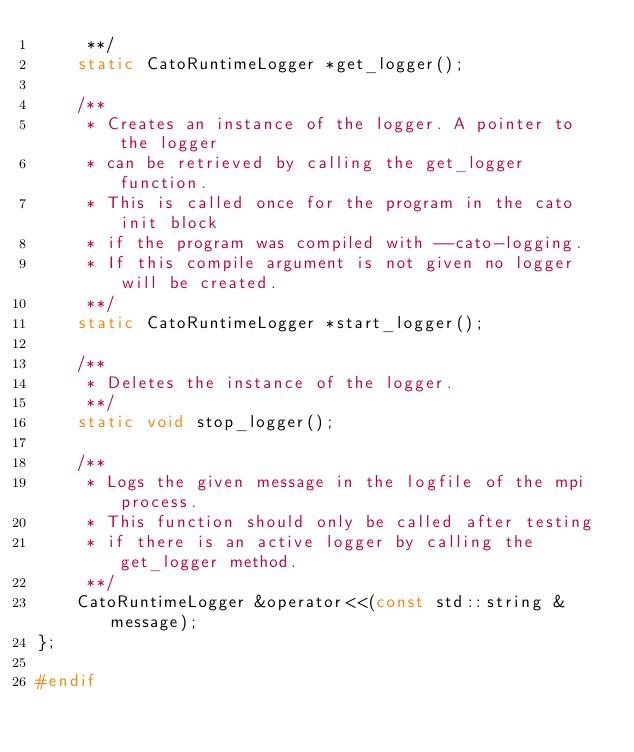<code> <loc_0><loc_0><loc_500><loc_500><_C_>     **/
    static CatoRuntimeLogger *get_logger();

    /**
     * Creates an instance of the logger. A pointer to the logger
     * can be retrieved by calling the get_logger function.
     * This is called once for the program in the cato init block
     * if the program was compiled with --cato-logging.
     * If this compile argument is not given no logger will be created.
     **/
    static CatoRuntimeLogger *start_logger();

    /**
     * Deletes the instance of the logger.
     **/
    static void stop_logger();

    /**
     * Logs the given message in the logfile of the mpi process.
     * This function should only be called after testing
     * if there is an active logger by calling the get_logger method.
     **/
    CatoRuntimeLogger &operator<<(const std::string &message);
};

#endif
</code> 